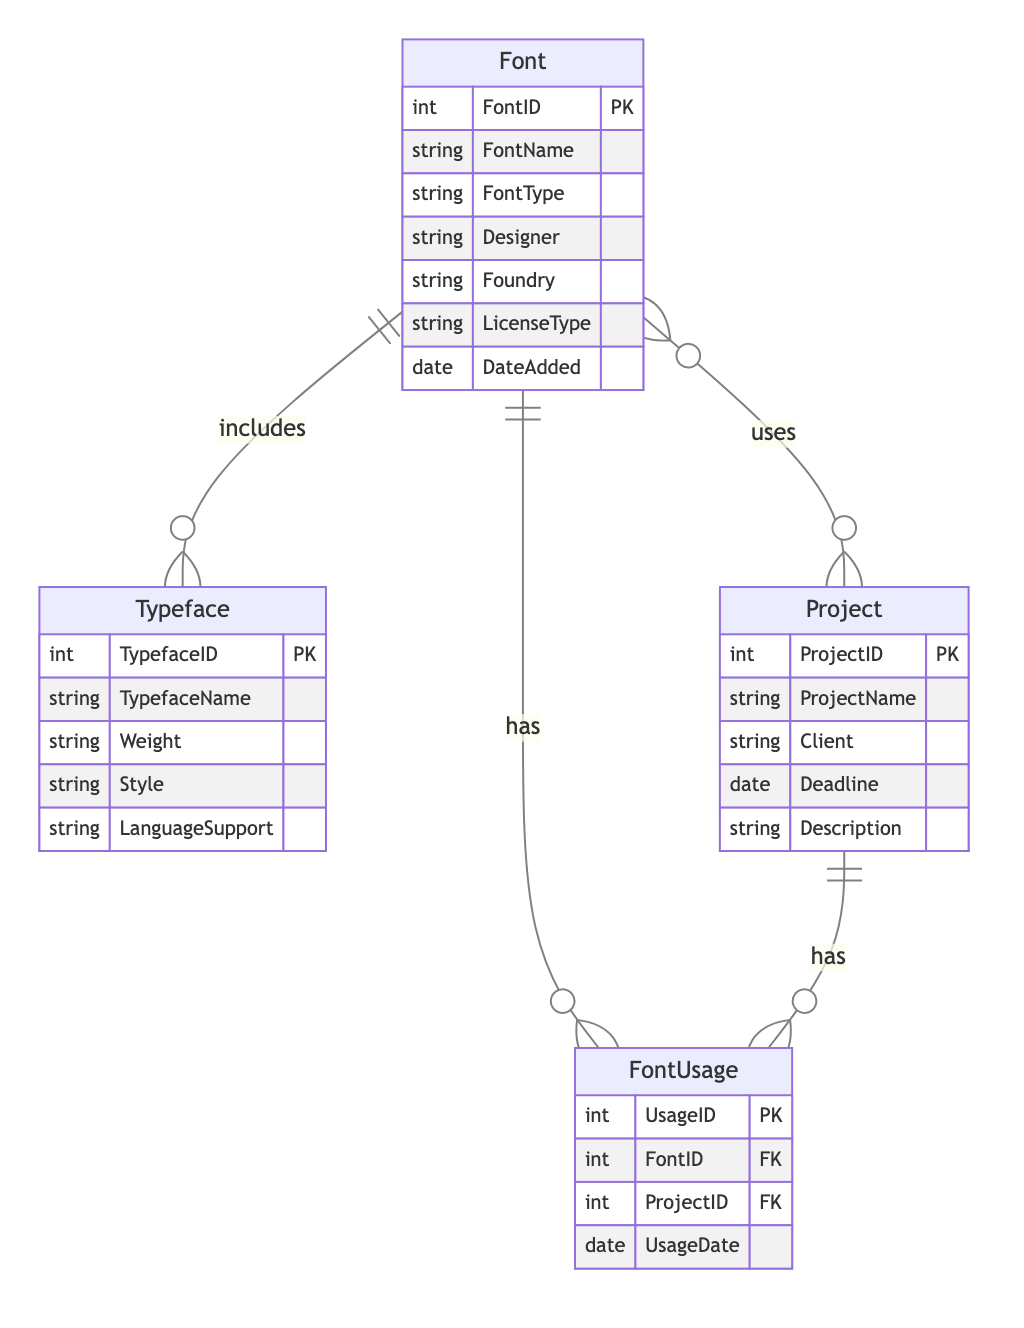What is the primary key of the Font entity? The primary key is identified within the Font entity as FontID, which uniquely identifies each font record.
Answer: FontID How many attributes are there in the Project entity? The Project entity comprises five attributes: ProjectID, ProjectName, Client, Deadline, and Description.
Answer: 5 What type of relationship exists between Font and Project? The relationship is defined as many-to-many, meaning multiple fonts can be used in multiple projects. This is represented by the FontUsage entity.
Answer: many-to-many Which entity has a one-to-many relationship with Typeface? The Font entity is the one that includes the Typeface entity in a one-to-many relationship; one font can correspond to multiple typefaces.
Answer: Font What does the FontUsage entity represent? The FontUsage entity indicates the usage of fonts in various projects, storing records that link FontID and ProjectID along with the date of usage.
Answer: Usage records How many total entities are present in the diagram? There are four distinct entities represented in the diagram: Font, Project, Typeface, and FontUsage.
Answer: 4 In the relationship structure, how many foreign keys does the FontUsage entity have? The FontUsage entity contains two foreign keys: FontID and ProjectID, which link to the Font and Project entities, respectively.
Answer: 2 What is the purpose of the includes relationship? The includes relationship specifies that each font may include one or more typefaces, highlighting a hierarchy and classification of fonts under various typefaces.
Answer: Font to Typeface How is the DateAdded attribute categorized in the Font entity? The DateAdded attribute is categorized as a date type, which signifies the date on which the font was added to the inventory.
Answer: date type 